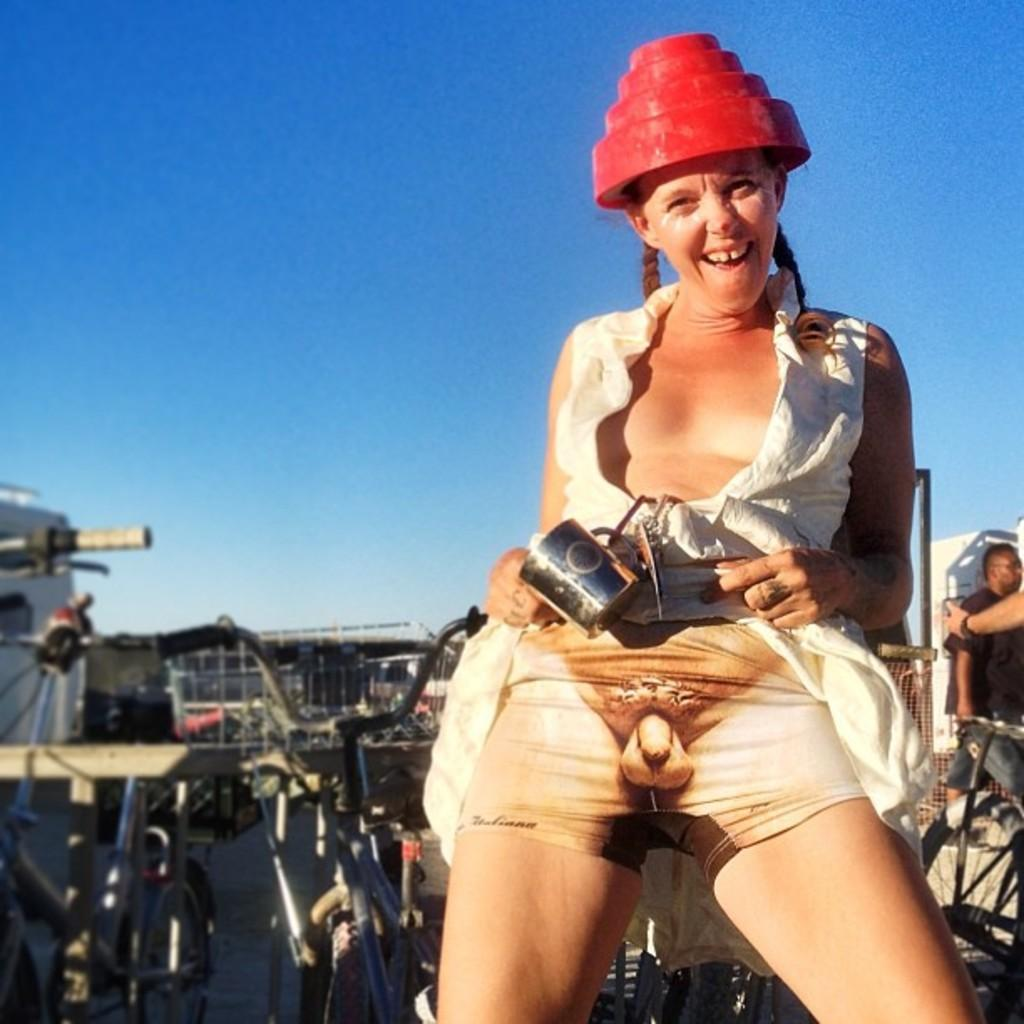What is the person in the image holding? There is a person standing holding an object in the image. What can be seen on the backside of the person? There are metal objects visible on the backside of the person. Can you describe the other person in the image? There is another person standing in the background. What is visible in the sky in the image? The sky is visible in the image, and it appears to be cloudy. What direction is the ladybug flying in the image? There is no ladybug present in the image, so it is not possible to determine the direction in which it might be flying. 